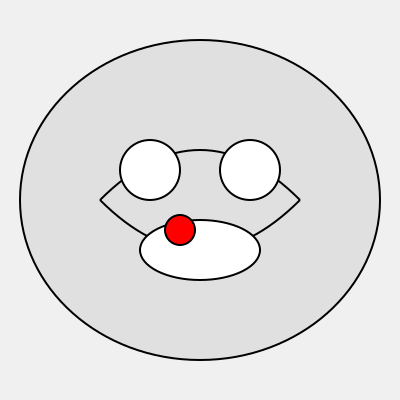Based on the brain MRI scan provided, what is the most likely diagnosis for this patient presenting with sudden onset of severe headache and confusion? To interpret this brain MRI scan and diagnose the neurological condition, let's follow these steps:

1. Orientation: The image shows a coronal (front-to-back) view of the brain.

2. Anatomy identification:
   - The two large circular structures at the top are the cerebral hemispheres.
   - The two smaller circular structures in the middle are the lateral ventricles.
   - The oval structure at the bottom is the brainstem.

3. Abnormality detection: There is a small, circular area of high signal intensity (represented by the red circle) in the left basal ganglia region.

4. Characteristics of the abnormality:
   - Location: Left basal ganglia
   - Size: Relatively small, approximately 1-2 cm in diameter
   - Shape: Round and well-defined
   - Signal intensity: Hyperintense (bright) compared to surrounding tissue

5. Clinical correlation:
   - Sudden onset of severe headache suggests a vascular event.
   - Confusion indicates a significant impact on brain function.
   - The location and appearance of the lesion are consistent with an acute hemorrhage.

6. Differential diagnosis:
   - Intracerebral hemorrhage (ICH) is the most likely diagnosis given the imaging findings and clinical presentation.
   - Other possibilities like ischemic stroke or tumor are less likely due to the sudden onset and imaging characteristics.

7. Conclusion: The imaging findings of a small, round, hyperintense lesion in the left basal ganglia, combined with the clinical presentation of sudden severe headache and confusion, are most consistent with an acute intracerebral hemorrhage.
Answer: Acute intracerebral hemorrhage (ICH) 